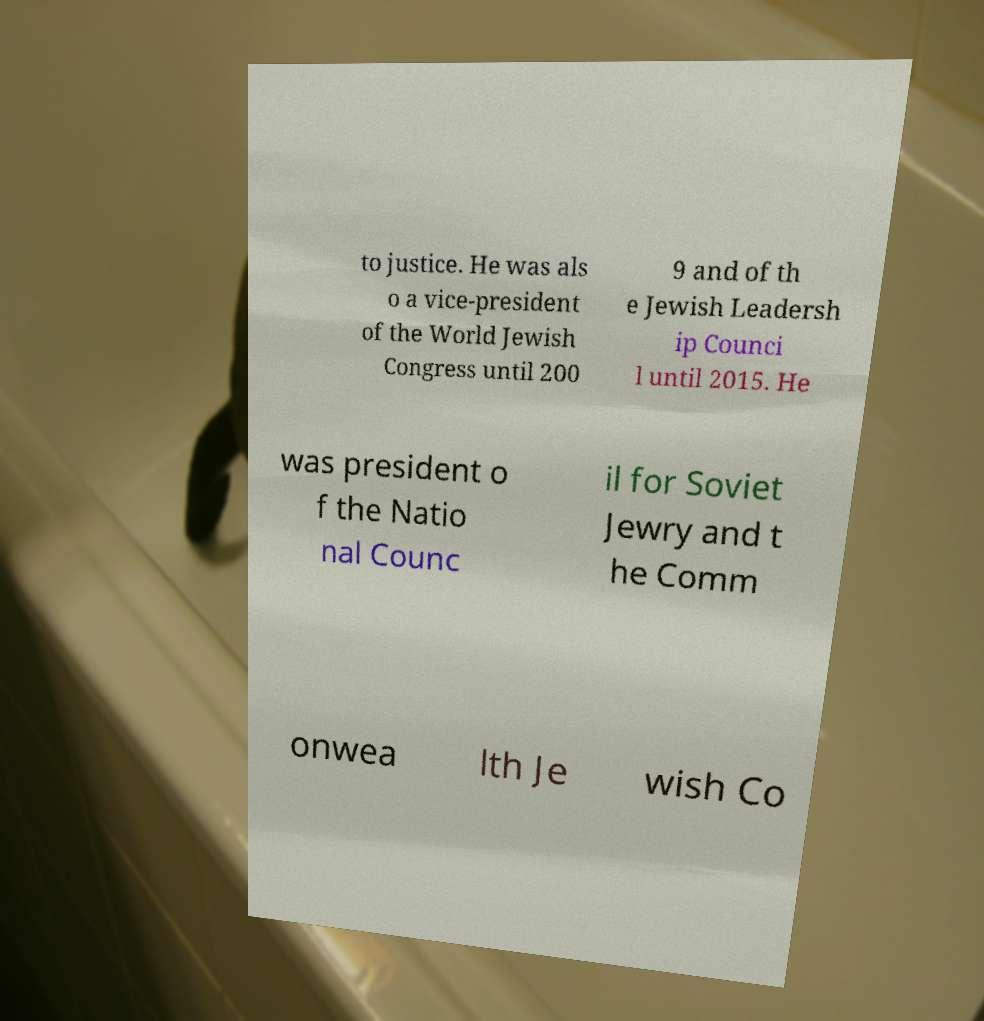Could you extract and type out the text from this image? to justice. He was als o a vice-president of the World Jewish Congress until 200 9 and of th e Jewish Leadersh ip Counci l until 2015. He was president o f the Natio nal Counc il for Soviet Jewry and t he Comm onwea lth Je wish Co 